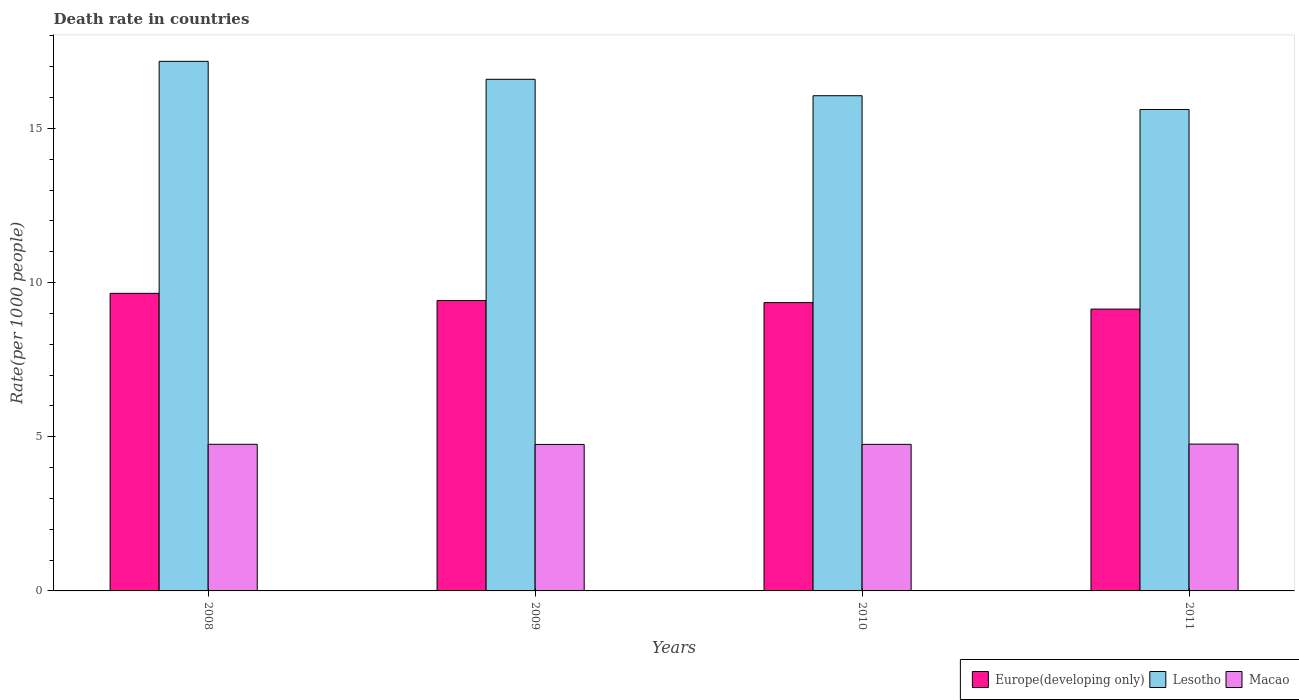Are the number of bars on each tick of the X-axis equal?
Provide a short and direct response. Yes. How many bars are there on the 1st tick from the left?
Offer a very short reply. 3. What is the death rate in Lesotho in 2010?
Make the answer very short. 16.06. Across all years, what is the maximum death rate in Europe(developing only)?
Ensure brevity in your answer.  9.65. Across all years, what is the minimum death rate in Macao?
Offer a terse response. 4.75. In which year was the death rate in Europe(developing only) maximum?
Your answer should be very brief. 2008. What is the total death rate in Lesotho in the graph?
Offer a very short reply. 65.45. What is the difference between the death rate in Europe(developing only) in 2008 and that in 2010?
Your answer should be compact. 0.3. What is the difference between the death rate in Europe(developing only) in 2008 and the death rate in Lesotho in 2010?
Offer a very short reply. -6.41. What is the average death rate in Lesotho per year?
Keep it short and to the point. 16.36. In the year 2008, what is the difference between the death rate in Lesotho and death rate in Macao?
Offer a very short reply. 12.42. In how many years, is the death rate in Europe(developing only) greater than 5?
Provide a short and direct response. 4. What is the ratio of the death rate in Europe(developing only) in 2010 to that in 2011?
Provide a succinct answer. 1.02. Is the death rate in Lesotho in 2008 less than that in 2009?
Give a very brief answer. No. What is the difference between the highest and the second highest death rate in Lesotho?
Ensure brevity in your answer.  0.58. What is the difference between the highest and the lowest death rate in Lesotho?
Offer a terse response. 1.56. In how many years, is the death rate in Macao greater than the average death rate in Macao taken over all years?
Your answer should be very brief. 2. What does the 3rd bar from the left in 2009 represents?
Your answer should be compact. Macao. What does the 1st bar from the right in 2011 represents?
Your answer should be compact. Macao. How many bars are there?
Ensure brevity in your answer.  12. Does the graph contain any zero values?
Offer a terse response. No. Does the graph contain grids?
Offer a terse response. No. Where does the legend appear in the graph?
Provide a succinct answer. Bottom right. How are the legend labels stacked?
Keep it short and to the point. Horizontal. What is the title of the graph?
Provide a short and direct response. Death rate in countries. What is the label or title of the Y-axis?
Your answer should be compact. Rate(per 1000 people). What is the Rate(per 1000 people) of Europe(developing only) in 2008?
Ensure brevity in your answer.  9.65. What is the Rate(per 1000 people) in Lesotho in 2008?
Provide a short and direct response. 17.18. What is the Rate(per 1000 people) in Macao in 2008?
Keep it short and to the point. 4.76. What is the Rate(per 1000 people) of Europe(developing only) in 2009?
Offer a very short reply. 9.42. What is the Rate(per 1000 people) in Lesotho in 2009?
Keep it short and to the point. 16.59. What is the Rate(per 1000 people) in Macao in 2009?
Your answer should be very brief. 4.75. What is the Rate(per 1000 people) of Europe(developing only) in 2010?
Offer a terse response. 9.35. What is the Rate(per 1000 people) in Lesotho in 2010?
Provide a short and direct response. 16.06. What is the Rate(per 1000 people) in Macao in 2010?
Your answer should be compact. 4.75. What is the Rate(per 1000 people) in Europe(developing only) in 2011?
Offer a terse response. 9.14. What is the Rate(per 1000 people) in Lesotho in 2011?
Keep it short and to the point. 15.62. What is the Rate(per 1000 people) in Macao in 2011?
Give a very brief answer. 4.76. Across all years, what is the maximum Rate(per 1000 people) in Europe(developing only)?
Your answer should be very brief. 9.65. Across all years, what is the maximum Rate(per 1000 people) in Lesotho?
Your answer should be compact. 17.18. Across all years, what is the maximum Rate(per 1000 people) in Macao?
Offer a terse response. 4.76. Across all years, what is the minimum Rate(per 1000 people) in Europe(developing only)?
Your response must be concise. 9.14. Across all years, what is the minimum Rate(per 1000 people) in Lesotho?
Your response must be concise. 15.62. Across all years, what is the minimum Rate(per 1000 people) in Macao?
Keep it short and to the point. 4.75. What is the total Rate(per 1000 people) in Europe(developing only) in the graph?
Offer a terse response. 37.56. What is the total Rate(per 1000 people) in Lesotho in the graph?
Ensure brevity in your answer.  65.45. What is the total Rate(per 1000 people) of Macao in the graph?
Provide a short and direct response. 19.02. What is the difference between the Rate(per 1000 people) in Europe(developing only) in 2008 and that in 2009?
Provide a short and direct response. 0.23. What is the difference between the Rate(per 1000 people) in Lesotho in 2008 and that in 2009?
Offer a very short reply. 0.58. What is the difference between the Rate(per 1000 people) of Macao in 2008 and that in 2009?
Your response must be concise. 0.01. What is the difference between the Rate(per 1000 people) in Europe(developing only) in 2008 and that in 2010?
Your response must be concise. 0.3. What is the difference between the Rate(per 1000 people) of Lesotho in 2008 and that in 2010?
Ensure brevity in your answer.  1.11. What is the difference between the Rate(per 1000 people) in Macao in 2008 and that in 2010?
Keep it short and to the point. 0. What is the difference between the Rate(per 1000 people) in Europe(developing only) in 2008 and that in 2011?
Provide a short and direct response. 0.51. What is the difference between the Rate(per 1000 people) of Lesotho in 2008 and that in 2011?
Offer a very short reply. 1.56. What is the difference between the Rate(per 1000 people) in Macao in 2008 and that in 2011?
Your response must be concise. -0.01. What is the difference between the Rate(per 1000 people) of Europe(developing only) in 2009 and that in 2010?
Provide a succinct answer. 0.07. What is the difference between the Rate(per 1000 people) in Lesotho in 2009 and that in 2010?
Offer a very short reply. 0.53. What is the difference between the Rate(per 1000 people) of Macao in 2009 and that in 2010?
Your answer should be very brief. -0. What is the difference between the Rate(per 1000 people) in Europe(developing only) in 2009 and that in 2011?
Ensure brevity in your answer.  0.28. What is the difference between the Rate(per 1000 people) of Macao in 2009 and that in 2011?
Ensure brevity in your answer.  -0.01. What is the difference between the Rate(per 1000 people) of Europe(developing only) in 2010 and that in 2011?
Give a very brief answer. 0.21. What is the difference between the Rate(per 1000 people) in Lesotho in 2010 and that in 2011?
Keep it short and to the point. 0.45. What is the difference between the Rate(per 1000 people) of Macao in 2010 and that in 2011?
Ensure brevity in your answer.  -0.01. What is the difference between the Rate(per 1000 people) in Europe(developing only) in 2008 and the Rate(per 1000 people) in Lesotho in 2009?
Ensure brevity in your answer.  -6.94. What is the difference between the Rate(per 1000 people) of Europe(developing only) in 2008 and the Rate(per 1000 people) of Macao in 2009?
Your answer should be compact. 4.9. What is the difference between the Rate(per 1000 people) of Lesotho in 2008 and the Rate(per 1000 people) of Macao in 2009?
Provide a succinct answer. 12.43. What is the difference between the Rate(per 1000 people) of Europe(developing only) in 2008 and the Rate(per 1000 people) of Lesotho in 2010?
Your answer should be very brief. -6.41. What is the difference between the Rate(per 1000 people) in Europe(developing only) in 2008 and the Rate(per 1000 people) in Macao in 2010?
Ensure brevity in your answer.  4.9. What is the difference between the Rate(per 1000 people) in Lesotho in 2008 and the Rate(per 1000 people) in Macao in 2010?
Ensure brevity in your answer.  12.42. What is the difference between the Rate(per 1000 people) in Europe(developing only) in 2008 and the Rate(per 1000 people) in Lesotho in 2011?
Give a very brief answer. -5.96. What is the difference between the Rate(per 1000 people) of Europe(developing only) in 2008 and the Rate(per 1000 people) of Macao in 2011?
Give a very brief answer. 4.89. What is the difference between the Rate(per 1000 people) in Lesotho in 2008 and the Rate(per 1000 people) in Macao in 2011?
Offer a terse response. 12.41. What is the difference between the Rate(per 1000 people) of Europe(developing only) in 2009 and the Rate(per 1000 people) of Lesotho in 2010?
Your answer should be compact. -6.64. What is the difference between the Rate(per 1000 people) of Europe(developing only) in 2009 and the Rate(per 1000 people) of Macao in 2010?
Offer a very short reply. 4.66. What is the difference between the Rate(per 1000 people) of Lesotho in 2009 and the Rate(per 1000 people) of Macao in 2010?
Keep it short and to the point. 11.84. What is the difference between the Rate(per 1000 people) in Europe(developing only) in 2009 and the Rate(per 1000 people) in Lesotho in 2011?
Give a very brief answer. -6.2. What is the difference between the Rate(per 1000 people) in Europe(developing only) in 2009 and the Rate(per 1000 people) in Macao in 2011?
Provide a short and direct response. 4.66. What is the difference between the Rate(per 1000 people) in Lesotho in 2009 and the Rate(per 1000 people) in Macao in 2011?
Offer a very short reply. 11.83. What is the difference between the Rate(per 1000 people) in Europe(developing only) in 2010 and the Rate(per 1000 people) in Lesotho in 2011?
Make the answer very short. -6.26. What is the difference between the Rate(per 1000 people) of Europe(developing only) in 2010 and the Rate(per 1000 people) of Macao in 2011?
Ensure brevity in your answer.  4.59. What is the difference between the Rate(per 1000 people) of Lesotho in 2010 and the Rate(per 1000 people) of Macao in 2011?
Provide a short and direct response. 11.3. What is the average Rate(per 1000 people) of Europe(developing only) per year?
Provide a short and direct response. 9.39. What is the average Rate(per 1000 people) of Lesotho per year?
Keep it short and to the point. 16.36. What is the average Rate(per 1000 people) in Macao per year?
Make the answer very short. 4.76. In the year 2008, what is the difference between the Rate(per 1000 people) in Europe(developing only) and Rate(per 1000 people) in Lesotho?
Keep it short and to the point. -7.52. In the year 2008, what is the difference between the Rate(per 1000 people) in Europe(developing only) and Rate(per 1000 people) in Macao?
Give a very brief answer. 4.9. In the year 2008, what is the difference between the Rate(per 1000 people) in Lesotho and Rate(per 1000 people) in Macao?
Your answer should be compact. 12.42. In the year 2009, what is the difference between the Rate(per 1000 people) of Europe(developing only) and Rate(per 1000 people) of Lesotho?
Provide a short and direct response. -7.18. In the year 2009, what is the difference between the Rate(per 1000 people) of Europe(developing only) and Rate(per 1000 people) of Macao?
Ensure brevity in your answer.  4.67. In the year 2009, what is the difference between the Rate(per 1000 people) of Lesotho and Rate(per 1000 people) of Macao?
Provide a succinct answer. 11.84. In the year 2010, what is the difference between the Rate(per 1000 people) of Europe(developing only) and Rate(per 1000 people) of Lesotho?
Give a very brief answer. -6.71. In the year 2010, what is the difference between the Rate(per 1000 people) of Europe(developing only) and Rate(per 1000 people) of Macao?
Offer a terse response. 4.6. In the year 2010, what is the difference between the Rate(per 1000 people) of Lesotho and Rate(per 1000 people) of Macao?
Your answer should be very brief. 11.31. In the year 2011, what is the difference between the Rate(per 1000 people) of Europe(developing only) and Rate(per 1000 people) of Lesotho?
Provide a short and direct response. -6.47. In the year 2011, what is the difference between the Rate(per 1000 people) of Europe(developing only) and Rate(per 1000 people) of Macao?
Your response must be concise. 4.38. In the year 2011, what is the difference between the Rate(per 1000 people) in Lesotho and Rate(per 1000 people) in Macao?
Your answer should be very brief. 10.85. What is the ratio of the Rate(per 1000 people) of Europe(developing only) in 2008 to that in 2009?
Make the answer very short. 1.02. What is the ratio of the Rate(per 1000 people) of Lesotho in 2008 to that in 2009?
Keep it short and to the point. 1.04. What is the ratio of the Rate(per 1000 people) of Macao in 2008 to that in 2009?
Keep it short and to the point. 1. What is the ratio of the Rate(per 1000 people) of Europe(developing only) in 2008 to that in 2010?
Your answer should be very brief. 1.03. What is the ratio of the Rate(per 1000 people) of Lesotho in 2008 to that in 2010?
Provide a short and direct response. 1.07. What is the ratio of the Rate(per 1000 people) of Macao in 2008 to that in 2010?
Your answer should be compact. 1. What is the ratio of the Rate(per 1000 people) of Europe(developing only) in 2008 to that in 2011?
Your answer should be compact. 1.06. What is the ratio of the Rate(per 1000 people) in Lesotho in 2008 to that in 2011?
Offer a very short reply. 1.1. What is the ratio of the Rate(per 1000 people) in Lesotho in 2009 to that in 2010?
Give a very brief answer. 1.03. What is the ratio of the Rate(per 1000 people) in Macao in 2009 to that in 2010?
Provide a short and direct response. 1. What is the ratio of the Rate(per 1000 people) of Europe(developing only) in 2009 to that in 2011?
Your response must be concise. 1.03. What is the ratio of the Rate(per 1000 people) of Lesotho in 2009 to that in 2011?
Your answer should be compact. 1.06. What is the ratio of the Rate(per 1000 people) in Europe(developing only) in 2010 to that in 2011?
Your answer should be very brief. 1.02. What is the ratio of the Rate(per 1000 people) of Lesotho in 2010 to that in 2011?
Offer a very short reply. 1.03. What is the difference between the highest and the second highest Rate(per 1000 people) in Europe(developing only)?
Provide a succinct answer. 0.23. What is the difference between the highest and the second highest Rate(per 1000 people) in Lesotho?
Offer a terse response. 0.58. What is the difference between the highest and the second highest Rate(per 1000 people) of Macao?
Give a very brief answer. 0.01. What is the difference between the highest and the lowest Rate(per 1000 people) of Europe(developing only)?
Offer a very short reply. 0.51. What is the difference between the highest and the lowest Rate(per 1000 people) in Lesotho?
Offer a terse response. 1.56. What is the difference between the highest and the lowest Rate(per 1000 people) of Macao?
Provide a succinct answer. 0.01. 